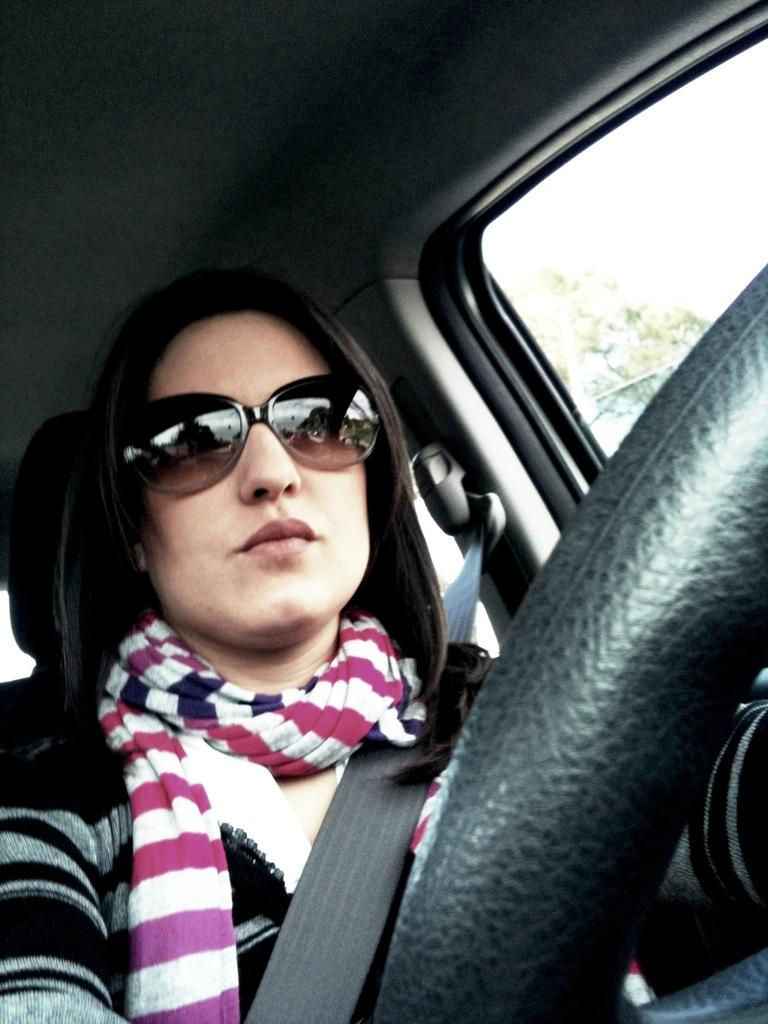Who is present in the image? There is a woman in the image. What is the woman wearing around her neck? The woman is wearing a scarf. What accessory is the woman wearing on her face? The woman is wearing glasses. Where is the woman located in the image? The woman is sitting inside a vehicle. What can be seen in the background of the image? There is a tree in the background of the image. What type of ball is the woman holding in the image? There is no ball present in the image; the woman is sitting inside a vehicle and wearing a scarf and glasses. 